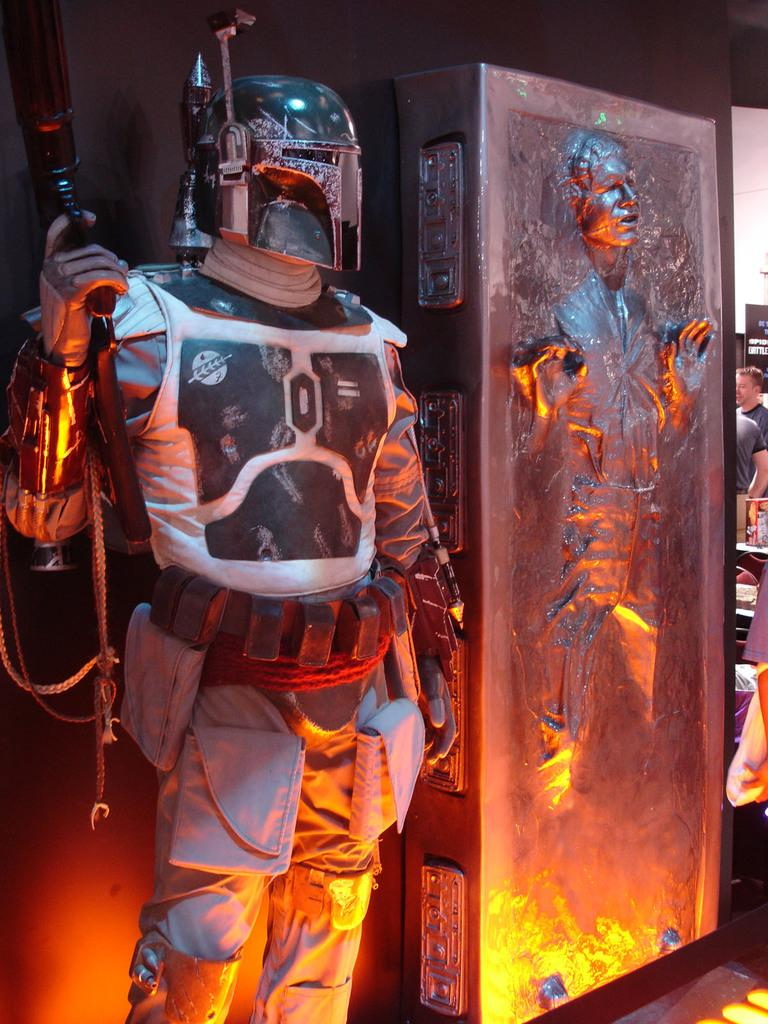Who can be seen in the image? There are people in the image. Can you describe the man on the left side of the image? The man on the left side of the image is wearing a suit. What is the man holding in the image? The man is holding a gun. What can be seen in the background of the image? There is a hoarding in the background of the image. What type of curtain is hanging in the image? There is no curtain present in the image. Can you tell me how many teeth the man has in the image? We cannot determine the number of teeth the man has in the image, as it does not show his teeth. 